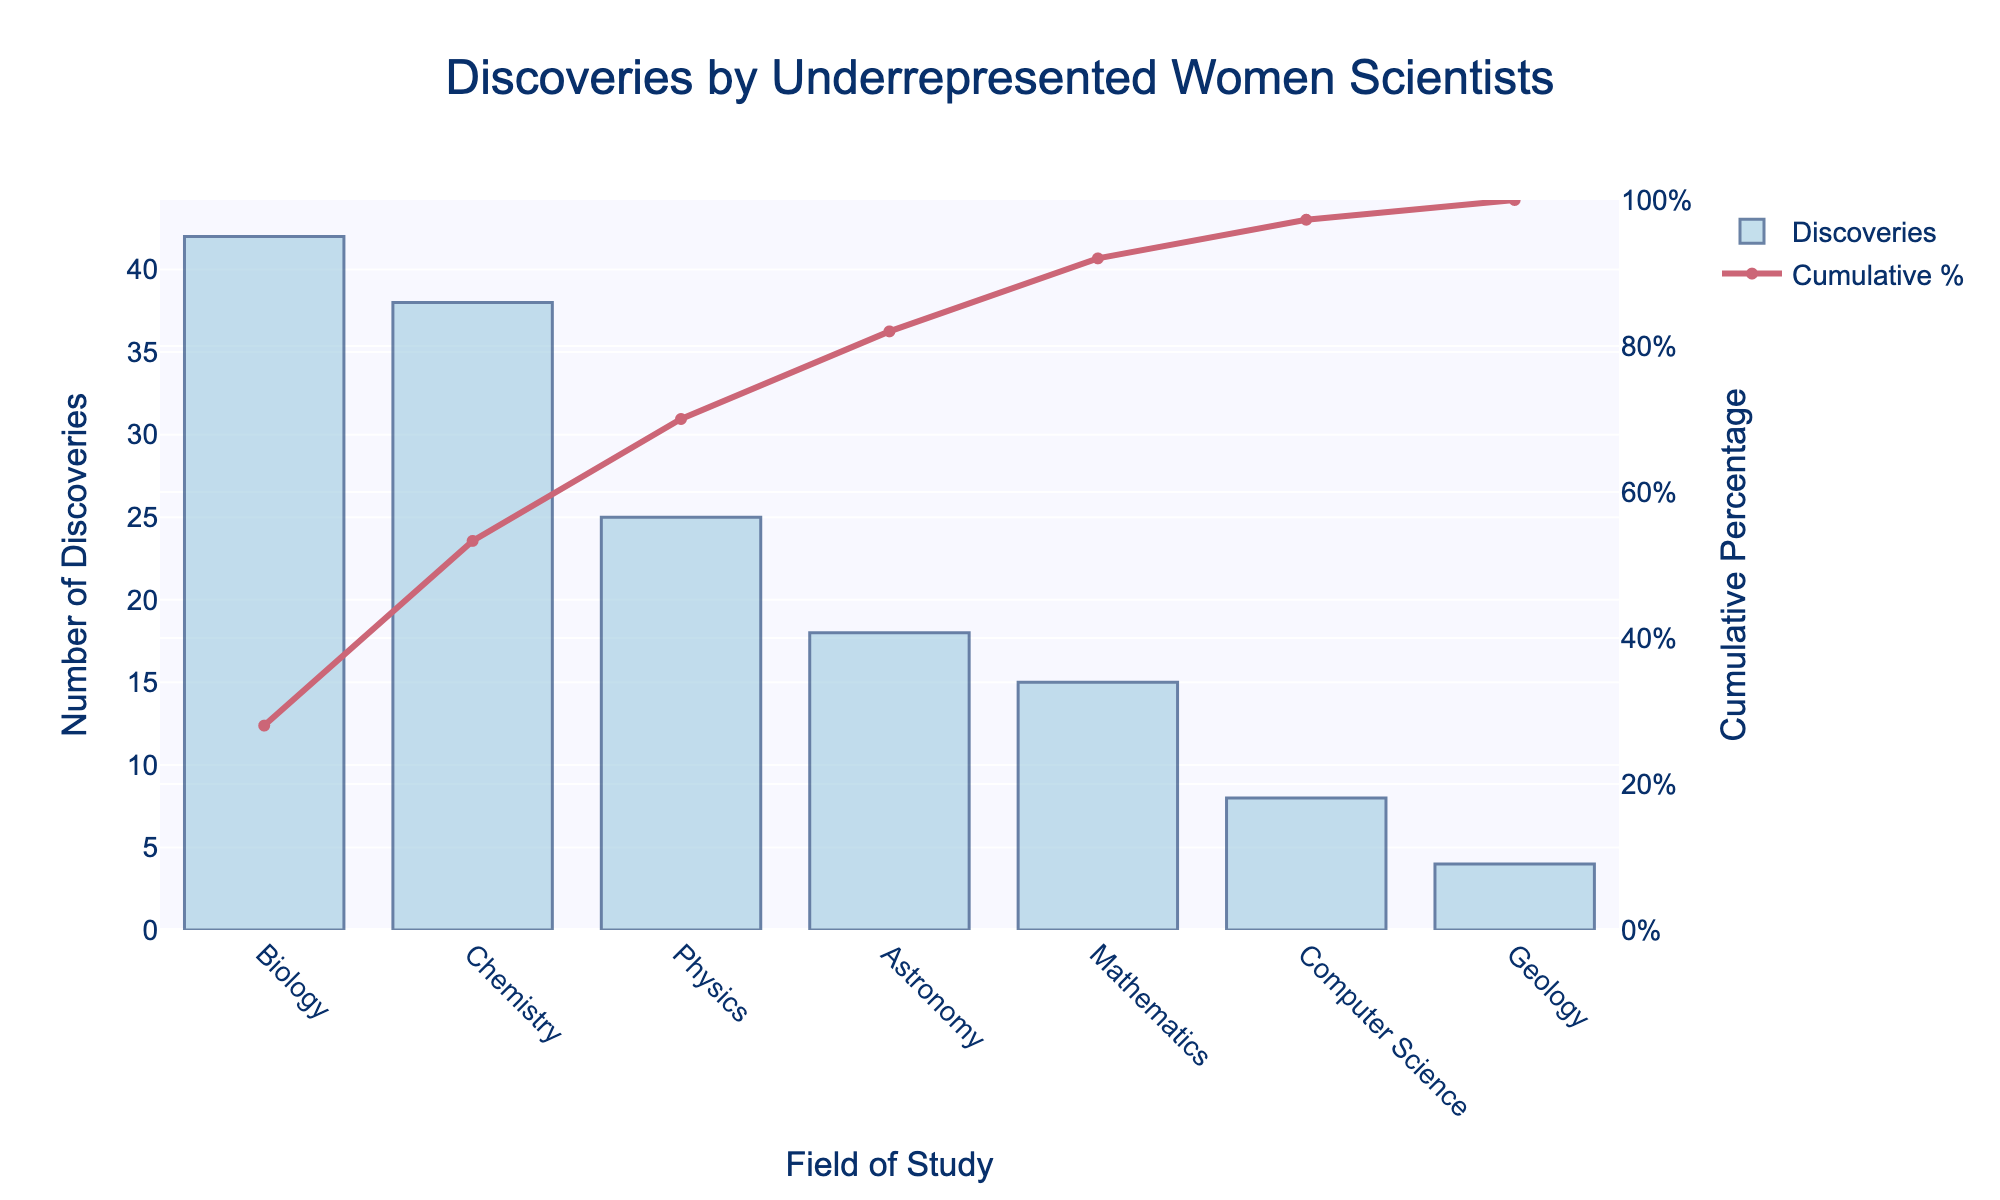What is the field with the highest number of discoveries? Refer to the tallest bar representing the highest number of discoveries. In the Pareto chart, the field with the highest bar is Biology.
Answer: Biology What percentage of total discoveries does the top field contribute? Refer to the Cumulative Percentage for the top field, which is Biology. The cumulative percentage value next to Biology is 28.0%.
Answer: 28.0% How many fields have a cumulative percentage of discoveries over 70%? Identify the fields where the cumulative percentage exceeds 70% by looking at the cumulative line. The fields are Astronomy, Mathematics, Computer Science, and Geology, which count up to 4 fields.
Answer: 4 What is the total number of discoveries made in Chemistry and Physics combined? Sum the number of discoveries for Chemistry and Physics. Chemistry has 38 discoveries and Physics has 25. So, 38 + 25 = 63.
Answer: 63 Which field has the lowest number of discoveries? Look at the shortest bar in the chart, which represents the field with the fewest discoveries. The shortest bar corresponds to Geology.
Answer: Geology How does the number of discoveries in Mathematics compare to those in Astronomy? Compare the bar heights for Mathematics and Astronomy. Mathematics has 15 discoveries while Astronomy has 18 discoveries.
Answer: Astronomy has more discoveries What is the cumulative percentage after all fields have been accounted for? Refer to the Cumulative Percentage at the last field listed, which is Geology. The cumulative percentage at Geology is 100.0%.
Answer: 100% What is the difference in cumulative percentage between the top two fields, Biology and Chemistry? Subtract the cumulative percentage of Chemistry from that of Biology. Chemistry has 53.3% and Biology has 28.0%. So, 53.3% - 28.0% = 25.3%.
Answer: 25.3% What is the median field in terms of the number of discoveries? Arrange the fields based on discoveries in ascending or descending order and find the middle value. The ordered fields are: Geology (4), Computer Science (8), Mathematics (15), Astronomy (18), Physics (25), Chemistry (38), Biology (42). The median field is Astronomy with 18 discoveries.
Answer: Astronomy Which fields together make up more than 50% of all discoveries? Refer to the cumulative percentages to find the fields up to just over 50%. Biology and Chemistry together have 28.0% + 25.3% = 53.3%.
Answer: Biology and Chemistry 